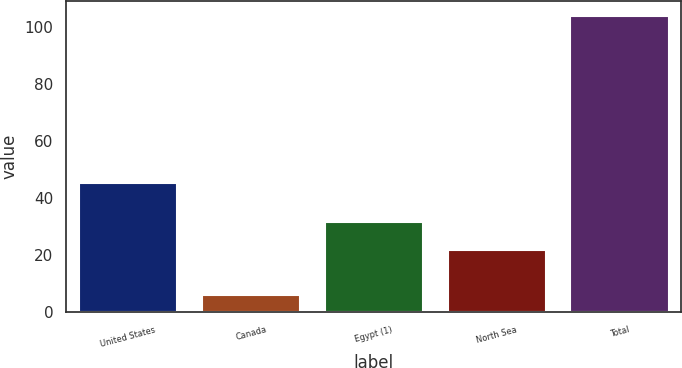Convert chart to OTSL. <chart><loc_0><loc_0><loc_500><loc_500><bar_chart><fcel>United States<fcel>Canada<fcel>Egypt (1)<fcel>North Sea<fcel>Total<nl><fcel>45.1<fcel>5.8<fcel>31.5<fcel>21.7<fcel>103.8<nl></chart> 